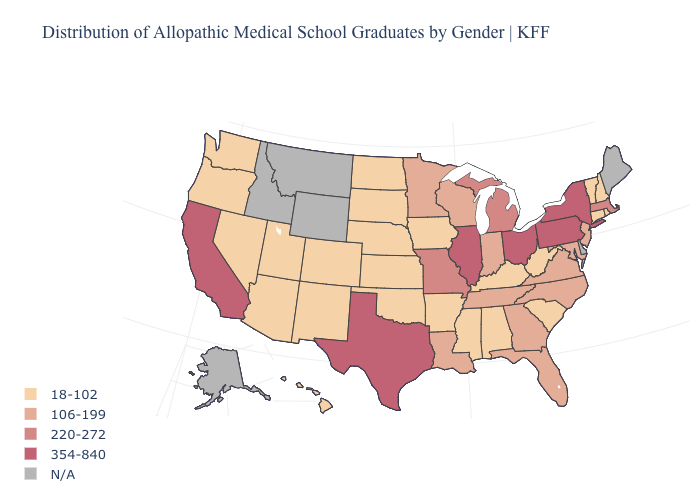Does the first symbol in the legend represent the smallest category?
Short answer required. Yes. What is the highest value in the USA?
Write a very short answer. 354-840. Name the states that have a value in the range 106-199?
Answer briefly. Florida, Georgia, Indiana, Louisiana, Maryland, Minnesota, New Jersey, North Carolina, Tennessee, Virginia, Wisconsin. Name the states that have a value in the range 354-840?
Write a very short answer. California, Illinois, New York, Ohio, Pennsylvania, Texas. What is the value of Louisiana?
Quick response, please. 106-199. What is the value of Connecticut?
Be succinct. 18-102. What is the value of Washington?
Give a very brief answer. 18-102. What is the value of Delaware?
Short answer required. N/A. What is the value of Virginia?
Give a very brief answer. 106-199. Name the states that have a value in the range 18-102?
Keep it brief. Alabama, Arizona, Arkansas, Colorado, Connecticut, Hawaii, Iowa, Kansas, Kentucky, Mississippi, Nebraska, Nevada, New Hampshire, New Mexico, North Dakota, Oklahoma, Oregon, Rhode Island, South Carolina, South Dakota, Utah, Vermont, Washington, West Virginia. Which states have the lowest value in the USA?
Answer briefly. Alabama, Arizona, Arkansas, Colorado, Connecticut, Hawaii, Iowa, Kansas, Kentucky, Mississippi, Nebraska, Nevada, New Hampshire, New Mexico, North Dakota, Oklahoma, Oregon, Rhode Island, South Carolina, South Dakota, Utah, Vermont, Washington, West Virginia. Among the states that border Maine , which have the lowest value?
Quick response, please. New Hampshire. What is the highest value in the MidWest ?
Be succinct. 354-840. What is the lowest value in states that border Wyoming?
Quick response, please. 18-102. 